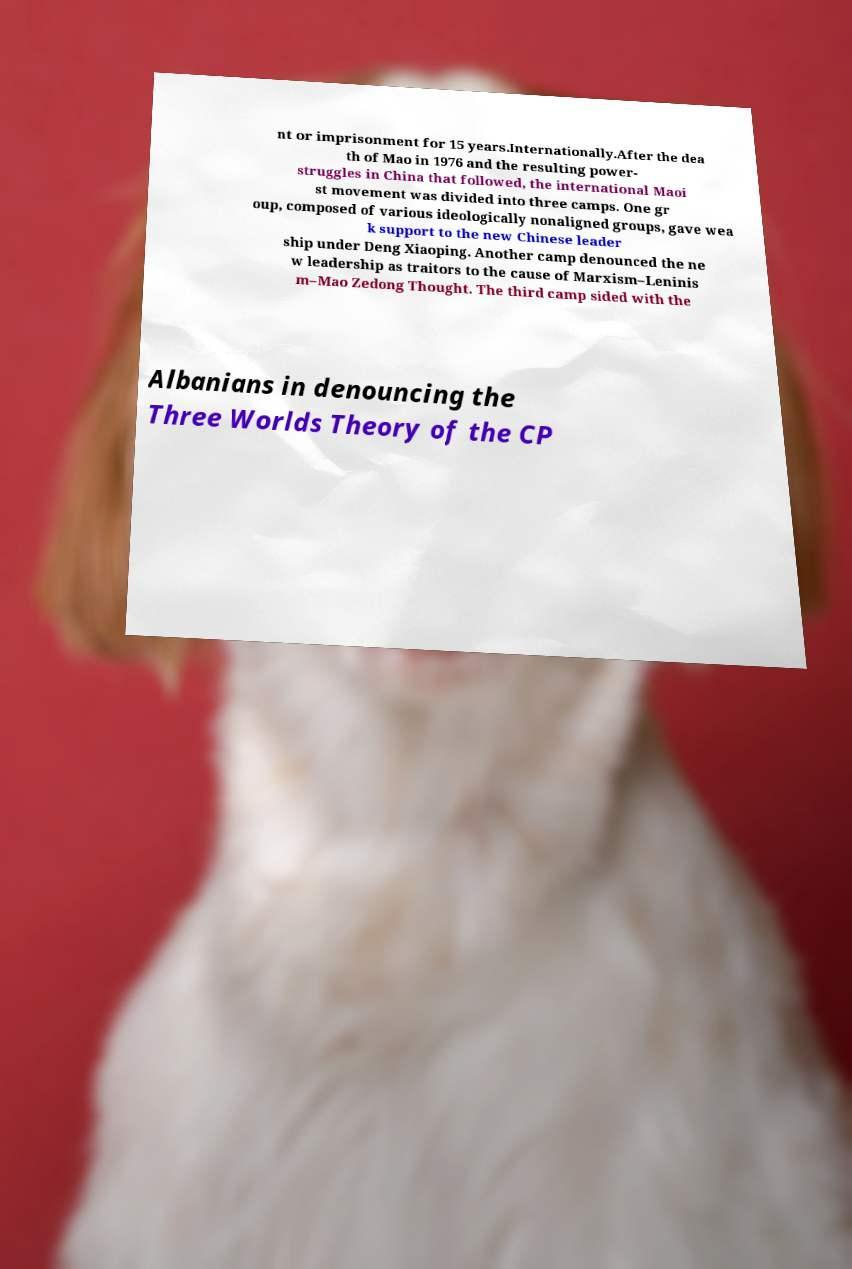Please read and relay the text visible in this image. What does it say? nt or imprisonment for 15 years.Internationally.After the dea th of Mao in 1976 and the resulting power- struggles in China that followed, the international Maoi st movement was divided into three camps. One gr oup, composed of various ideologically nonaligned groups, gave wea k support to the new Chinese leader ship under Deng Xiaoping. Another camp denounced the ne w leadership as traitors to the cause of Marxism–Leninis m–Mao Zedong Thought. The third camp sided with the Albanians in denouncing the Three Worlds Theory of the CP 